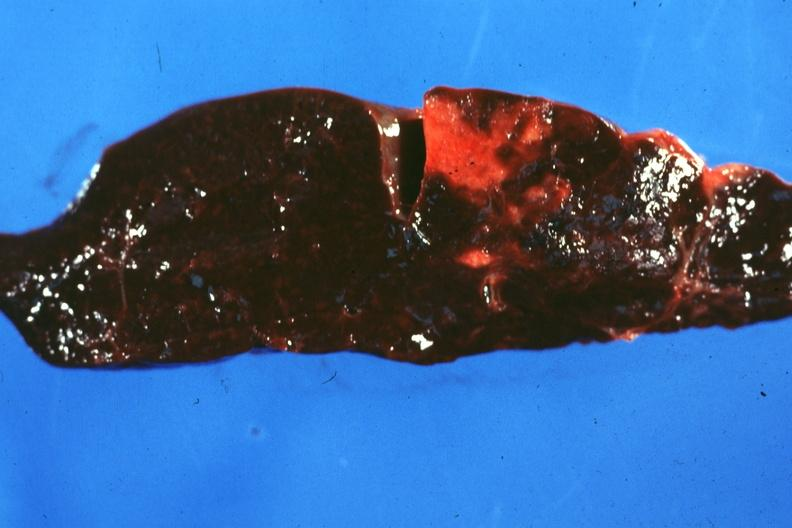s there present?
Answer the question using a single word or phrase. No 